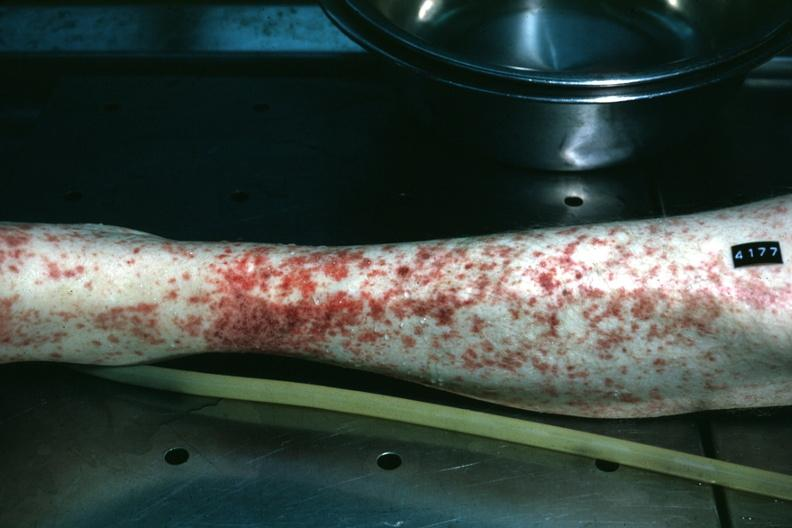what is present?
Answer the question using a single word or phrase. Petechial and purpuric hemorrhages 